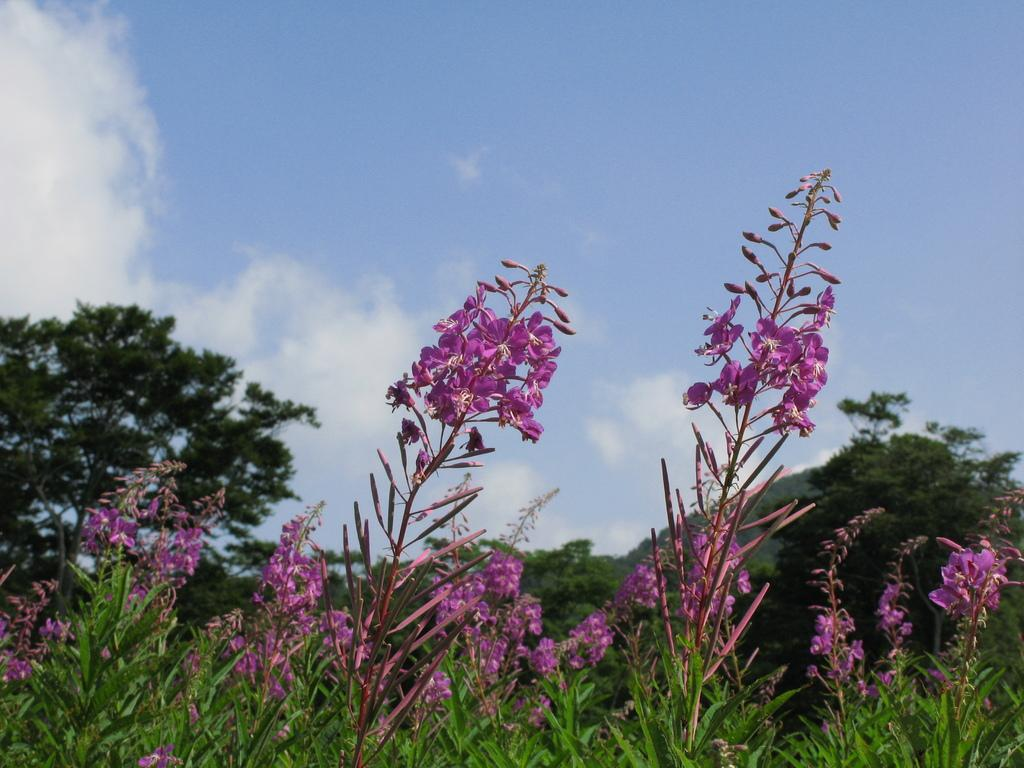What type of flora is present in the image? There are flowers in the image. Where are the flowers located? The flowers are on plants. What color are the flowers? The flowers are pink in color. What can be seen in the background of the image? There are trees, clouds, and the sky visible in the background of the image. What type of pollution can be seen affecting the flowers in the image? There is no indication of pollution affecting the flowers in the image. What type of pancake is being served on a plate in the image? There is no pancake present in the image. 